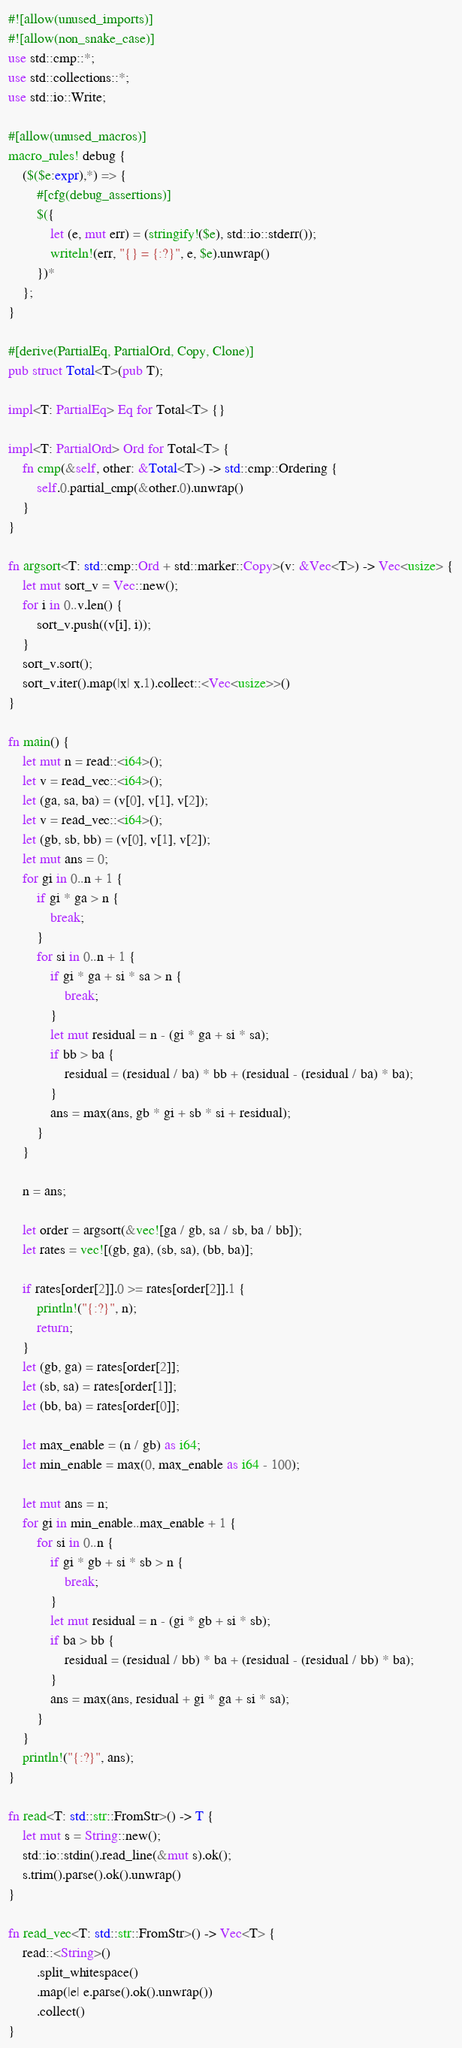Convert code to text. <code><loc_0><loc_0><loc_500><loc_500><_Rust_>#![allow(unused_imports)]
#![allow(non_snake_case)]
use std::cmp::*;
use std::collections::*;
use std::io::Write;

#[allow(unused_macros)]
macro_rules! debug {
    ($($e:expr),*) => {
        #[cfg(debug_assertions)]
        $({
            let (e, mut err) = (stringify!($e), std::io::stderr());
            writeln!(err, "{} = {:?}", e, $e).unwrap()
        })*
    };
}

#[derive(PartialEq, PartialOrd, Copy, Clone)]
pub struct Total<T>(pub T);

impl<T: PartialEq> Eq for Total<T> {}

impl<T: PartialOrd> Ord for Total<T> {
    fn cmp(&self, other: &Total<T>) -> std::cmp::Ordering {
        self.0.partial_cmp(&other.0).unwrap()
    }
}

fn argsort<T: std::cmp::Ord + std::marker::Copy>(v: &Vec<T>) -> Vec<usize> {
    let mut sort_v = Vec::new();
    for i in 0..v.len() {
        sort_v.push((v[i], i));
    }
    sort_v.sort();
    sort_v.iter().map(|x| x.1).collect::<Vec<usize>>()
}

fn main() {
    let mut n = read::<i64>();
    let v = read_vec::<i64>();
    let (ga, sa, ba) = (v[0], v[1], v[2]);
    let v = read_vec::<i64>();
    let (gb, sb, bb) = (v[0], v[1], v[2]);
    let mut ans = 0;
    for gi in 0..n + 1 {
        if gi * ga > n {
            break;
        }
        for si in 0..n + 1 {
            if gi * ga + si * sa > n {
                break;
            }
            let mut residual = n - (gi * ga + si * sa);
            if bb > ba {
                residual = (residual / ba) * bb + (residual - (residual / ba) * ba);
            }
            ans = max(ans, gb * gi + sb * si + residual);
        }
    }

    n = ans;

    let order = argsort(&vec![ga / gb, sa / sb, ba / bb]);
    let rates = vec![(gb, ga), (sb, sa), (bb, ba)];

    if rates[order[2]].0 >= rates[order[2]].1 {
        println!("{:?}", n);
        return;
    }
    let (gb, ga) = rates[order[2]];
    let (sb, sa) = rates[order[1]];
    let (bb, ba) = rates[order[0]];

    let max_enable = (n / gb) as i64;
    let min_enable = max(0, max_enable as i64 - 100);

    let mut ans = n;
    for gi in min_enable..max_enable + 1 {
        for si in 0..n {
            if gi * gb + si * sb > n {
                break;
            }
            let mut residual = n - (gi * gb + si * sb);
            if ba > bb {
                residual = (residual / bb) * ba + (residual - (residual / bb) * ba);
            }
            ans = max(ans, residual + gi * ga + si * sa);
        }
    }
    println!("{:?}", ans);
}

fn read<T: std::str::FromStr>() -> T {
    let mut s = String::new();
    std::io::stdin().read_line(&mut s).ok();
    s.trim().parse().ok().unwrap()
}

fn read_vec<T: std::str::FromStr>() -> Vec<T> {
    read::<String>()
        .split_whitespace()
        .map(|e| e.parse().ok().unwrap())
        .collect()
}
</code> 